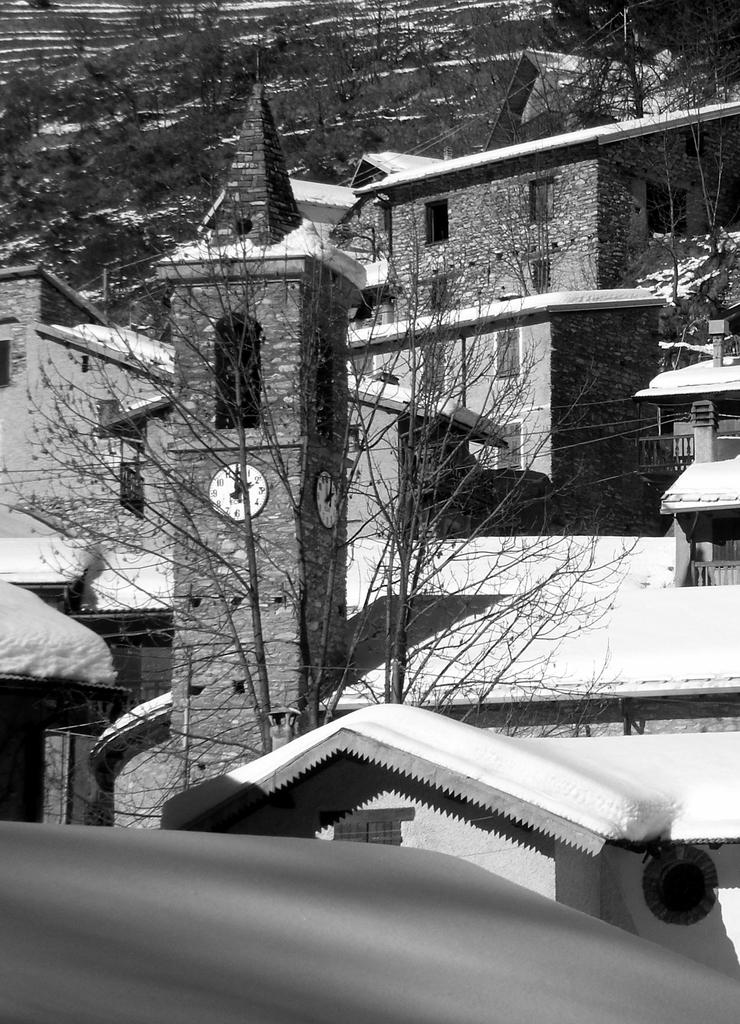What type of structures can be seen in the image? There are buildings in the image. What other elements are present in the image besides buildings? There are trees and wires in the image. What is the color scheme of the image? The image is black and white in color. How is the potato being distributed in the image? There is no potato present in the image, so there is no distribution happening. 